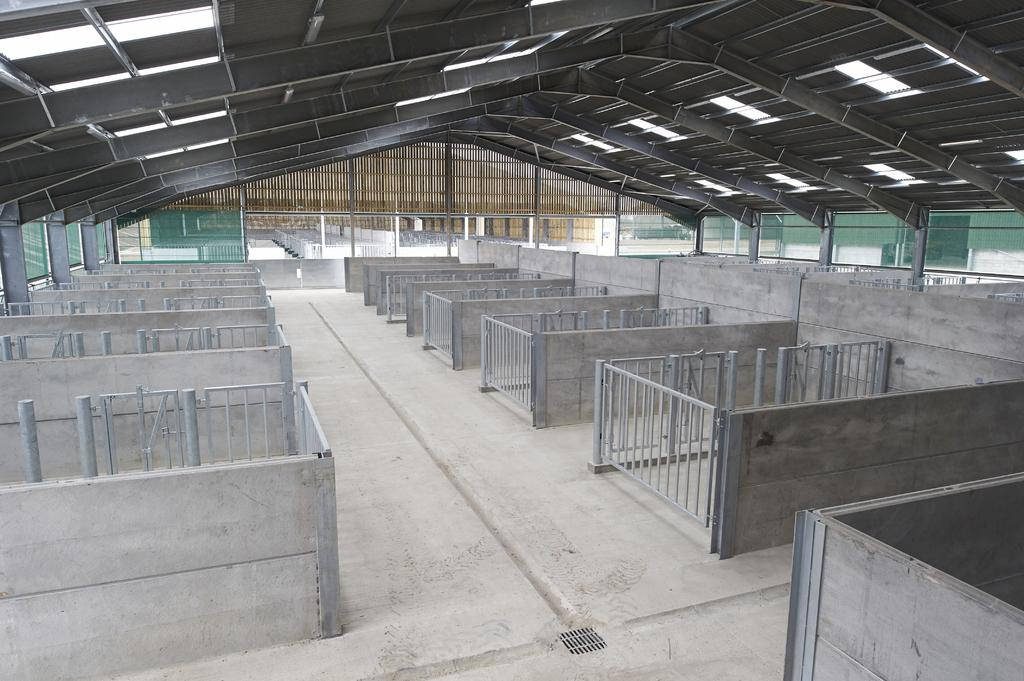What type of surface can be seen at the bottom of the image? There is ground visible in the image. What type of structure is present in the image? There is railing and walls visible in the image. What is located above the walls in the image? The ceiling is visible in the image. What can be seen in the distance in the image? There is another building in the background of the image. What time is displayed on the clock in the image? There is no clock present in the image. How do the people in the image say good-bye to each other? There are no people present in the image, so it is not possible to determine how they would say good-bye. 